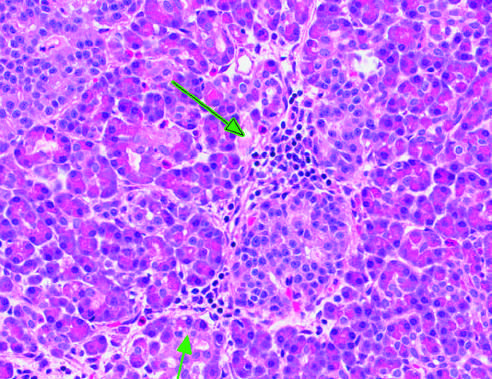do a few interspersed neutrophils, much smaller in size and with compact, lobate nuclei, point to inflammation surrounding islet of langerhans?
Answer the question using a single word or phrase. No 